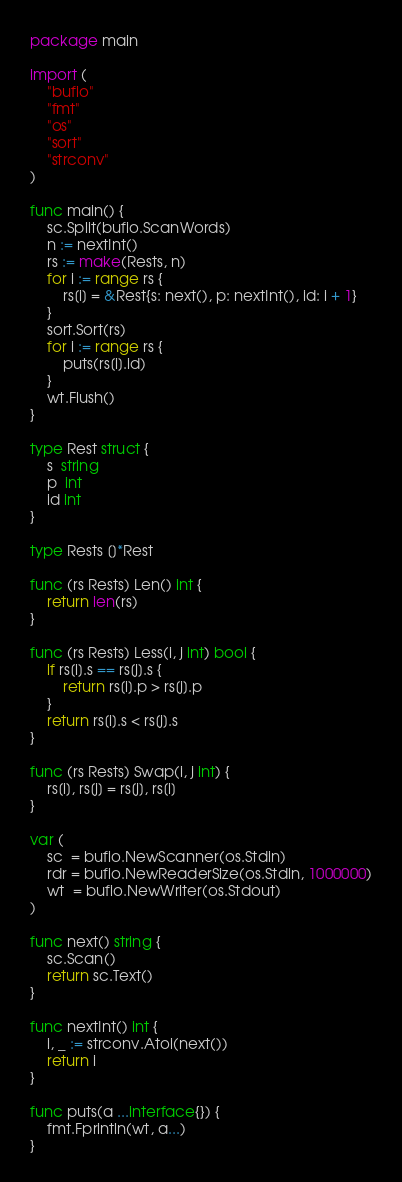<code> <loc_0><loc_0><loc_500><loc_500><_Go_>package main

import (
	"bufio"
	"fmt"
	"os"
	"sort"
	"strconv"
)

func main() {
	sc.Split(bufio.ScanWords)
	n := nextInt()
	rs := make(Rests, n)
	for i := range rs {
		rs[i] = &Rest{s: next(), p: nextInt(), id: i + 1}
	}
	sort.Sort(rs)
	for i := range rs {
		puts(rs[i].id)
	}
	wt.Flush()
}

type Rest struct {
	s  string
	p  int
	id int
}

type Rests []*Rest

func (rs Rests) Len() int {
	return len(rs)
}

func (rs Rests) Less(i, j int) bool {
	if rs[i].s == rs[j].s {
		return rs[i].p > rs[j].p
	}
	return rs[i].s < rs[j].s
}

func (rs Rests) Swap(i, j int) {
	rs[i], rs[j] = rs[j], rs[i]
}

var (
	sc  = bufio.NewScanner(os.Stdin)
	rdr = bufio.NewReaderSize(os.Stdin, 1000000)
	wt  = bufio.NewWriter(os.Stdout)
)

func next() string {
	sc.Scan()
	return sc.Text()
}

func nextInt() int {
	i, _ := strconv.Atoi(next())
	return i
}

func puts(a ...interface{}) {
	fmt.Fprintln(wt, a...)
}
</code> 